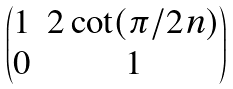<formula> <loc_0><loc_0><loc_500><loc_500>\begin{pmatrix} 1 & 2 \cot ( \pi / 2 n ) \\ 0 & 1 \end{pmatrix}</formula> 